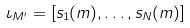Convert formula to latex. <formula><loc_0><loc_0><loc_500><loc_500>\iota _ { { M } ^ { \prime } } = [ s _ { 1 } ( m ) , \dots , s _ { N } ( m ) ]</formula> 